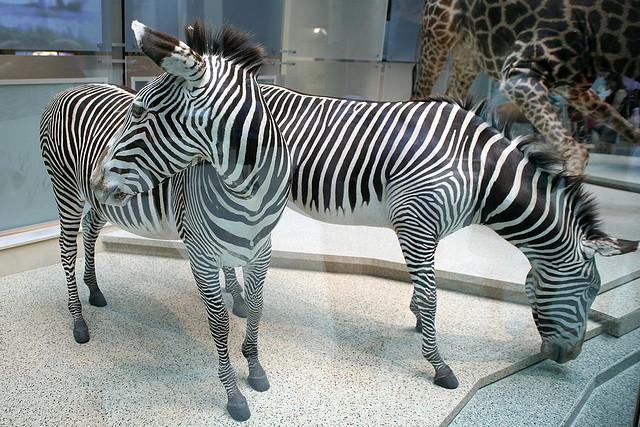Where are the giraffes?
Short answer required. In background. Are the animals real or fake?
Answer briefly. Fake. What is the black and white animal?
Keep it brief. Zebra. 